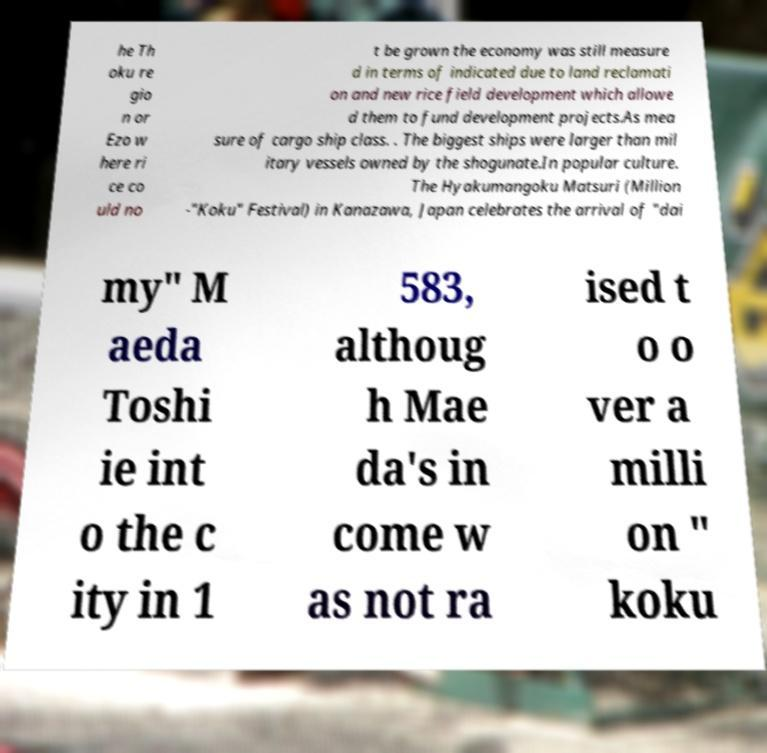Please read and relay the text visible in this image. What does it say? he Th oku re gio n or Ezo w here ri ce co uld no t be grown the economy was still measure d in terms of indicated due to land reclamati on and new rice field development which allowe d them to fund development projects.As mea sure of cargo ship class. . The biggest ships were larger than mil itary vessels owned by the shogunate.In popular culture. The Hyakumangoku Matsuri (Million -"Koku" Festival) in Kanazawa, Japan celebrates the arrival of "dai my" M aeda Toshi ie int o the c ity in 1 583, althoug h Mae da's in come w as not ra ised t o o ver a milli on " koku 